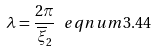Convert formula to latex. <formula><loc_0><loc_0><loc_500><loc_500>\lambda = \frac { 2 \pi } { \overline { \xi } _ { 2 } } \ e q n u m { 3 . 4 4 }</formula> 